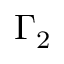Convert formula to latex. <formula><loc_0><loc_0><loc_500><loc_500>\Gamma _ { 2 }</formula> 